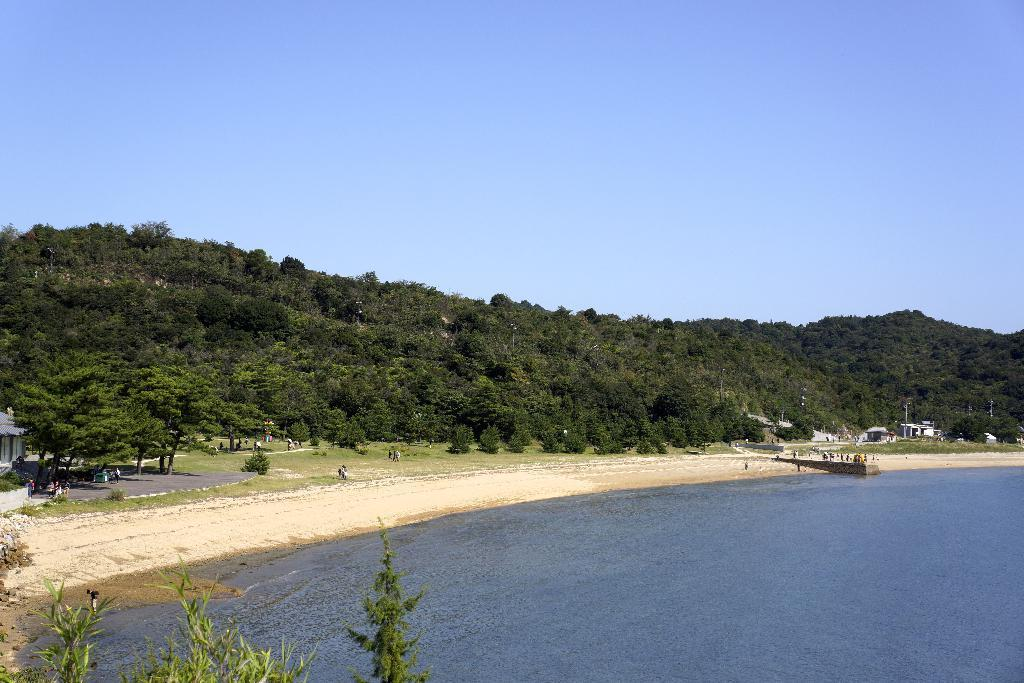What is the primary element in the image? There is water in the image. Can you describe the people in the image? There are people in the image. What can be seen beneath the people's feet? The ground is visible in the image. What type of path is present in the image? There is a path in the image. What type of vegetation is present in the image? Trees are present in the image. What type of structure is visible in the image? There is a house in the image. What type of natural formation is visible in the image? Mountains are visible in the image. What part of the natural environment is visible in the image? The sky is visible in the image. How many spiders are crawling on the egg in the image? There is no egg or spiders present in the image. What type of roll is being used to create the path in the image? There is no roll used to create the path in the image; it is a regular path made of a solid material. 